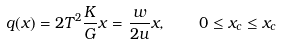Convert formula to latex. <formula><loc_0><loc_0><loc_500><loc_500>q ( x ) = 2 T ^ { 2 } \frac { K } { G } x = \frac { w } { 2 u } x , \quad 0 \leq x _ { c } \leq x _ { c }</formula> 